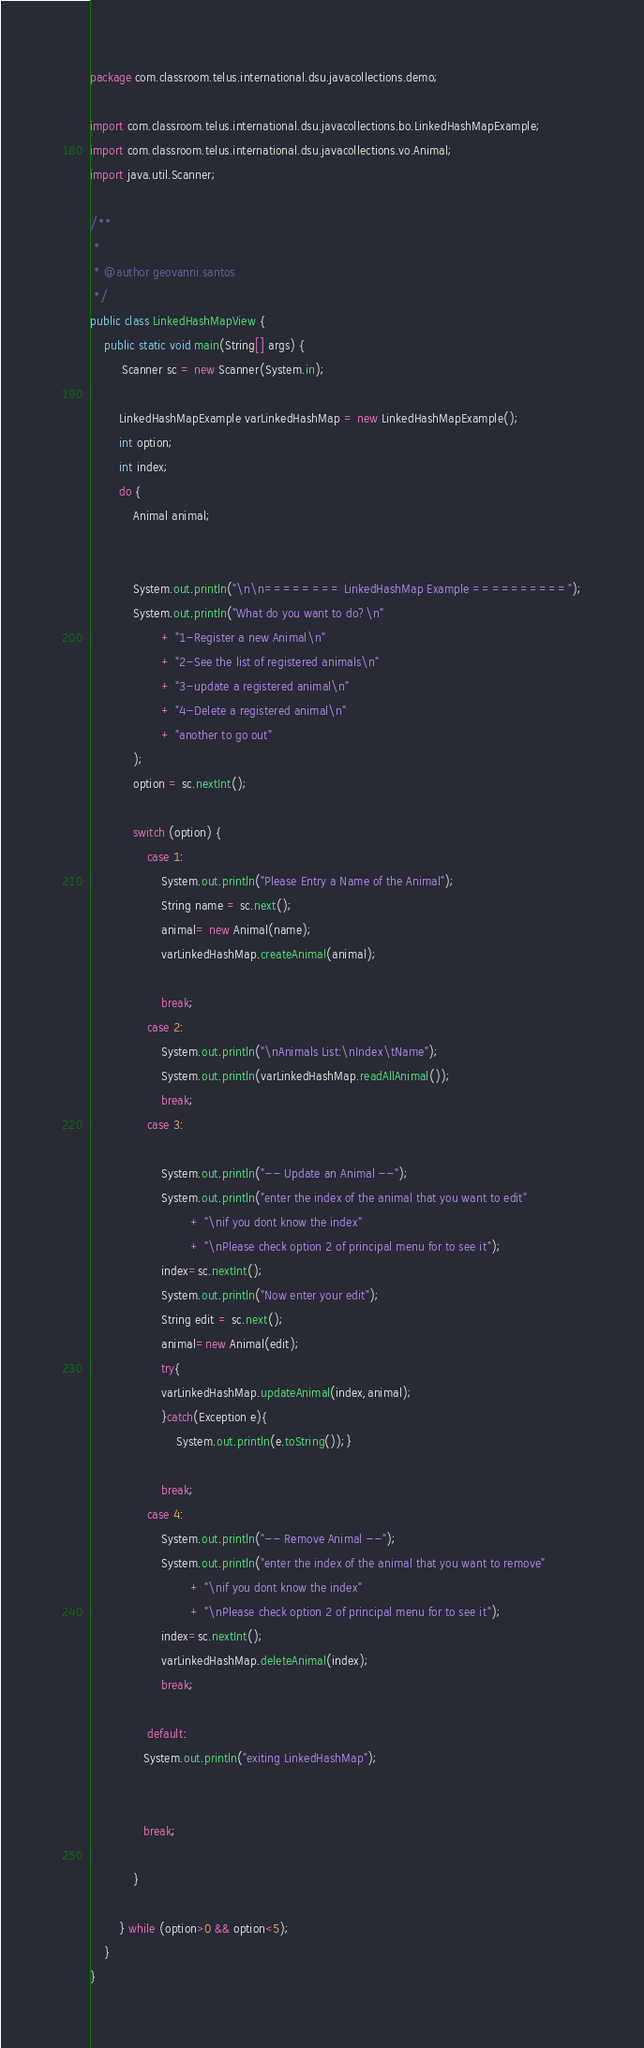Convert code to text. <code><loc_0><loc_0><loc_500><loc_500><_Java_>package com.classroom.telus.international.dsu.javacollections.demo;

import com.classroom.telus.international.dsu.javacollections.bo.LinkedHashMapExample;
import com.classroom.telus.international.dsu.javacollections.vo.Animal;
import java.util.Scanner;

/**
 *
 * @author geovanni.santos
 */
public class LinkedHashMapView {
    public static void main(String[] args) {
         Scanner sc = new Scanner(System.in);
        
        LinkedHashMapExample varLinkedHashMap = new LinkedHashMapExample();
        int option;
        int index;
        do {
            Animal animal;
         
         
            System.out.println("\n\n======== LinkedHashMap Example ==========");
            System.out.println("What do you want to do?\n"
                    + "1-Register a new Animal\n"
                    + "2-See the list of registered animals\n"
                    + "3-update a registered animal\n"
                    + "4-Delete a registered animal\n"
                    + "another to go out"
            );
            option = sc.nextInt();
            
            switch (option) {
                case 1:
                    System.out.println("Please Entry a Name of the Animal");
                    String name = sc.next();
                    animal= new Animal(name);
                    varLinkedHashMap.createAnimal(animal);                    
                    
                    break;
                case 2:
                    System.out.println("\nAnimals List:\nIndex\tName");
                    System.out.println(varLinkedHashMap.readAllAnimal());
                    break;
                case 3:
                   
                    System.out.println("-- Update an Animal --");
                    System.out.println("enter the index of the animal that you want to edit"
                            + "\nif you dont know the index"
                            + "\nPlease check option 2 of principal menu for to see it");
                    index=sc.nextInt();                    
                    System.out.println("Now enter your edit");
                    String edit = sc.next();
                    animal=new Animal(edit);
                    try{
                    varLinkedHashMap.updateAnimal(index,animal);   
                    }catch(Exception e){
                        System.out.println(e.toString());}
                    
                    break;
                case 4:
                    System.out.println("-- Remove Animal --");
                    System.out.println("enter the index of the animal that you want to remove"
                            + "\nif you dont know the index"
                            + "\nPlease check option 2 of principal menu for to see it");
                    index=sc.nextInt();              
                    varLinkedHashMap.deleteAnimal(index);                    
                    break;
                    
                default:
               System.out.println("exiting LinkedHashMap");
                       
                    
               break;
                
            }
            
        } while (option>0 && option<5);
    }
}
</code> 